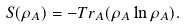<formula> <loc_0><loc_0><loc_500><loc_500>S ( \rho _ { A } ) = - T r _ { A } ( \rho _ { A } \ln \rho _ { A } ) .</formula> 